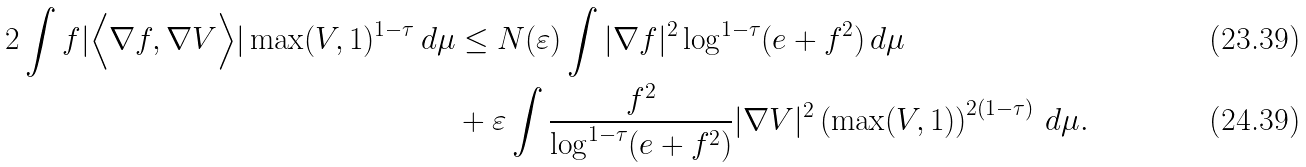Convert formula to latex. <formula><loc_0><loc_0><loc_500><loc_500>2 \int f | \Big < \nabla f , \nabla V \Big > | \max ( V , 1 ) ^ { 1 - \tau } \, d \mu & \leq N ( \varepsilon ) \int | \nabla f | ^ { 2 } \log ^ { 1 - \tau } ( e + f ^ { 2 } ) \, d \mu \\ & + \varepsilon \int \frac { f ^ { 2 } } { \log ^ { 1 - \tau } ( e + f ^ { 2 } ) } | \nabla V | ^ { 2 } \left ( \max ( V , 1 ) \right ) ^ { 2 ( 1 - \tau ) } \, d \mu .</formula> 